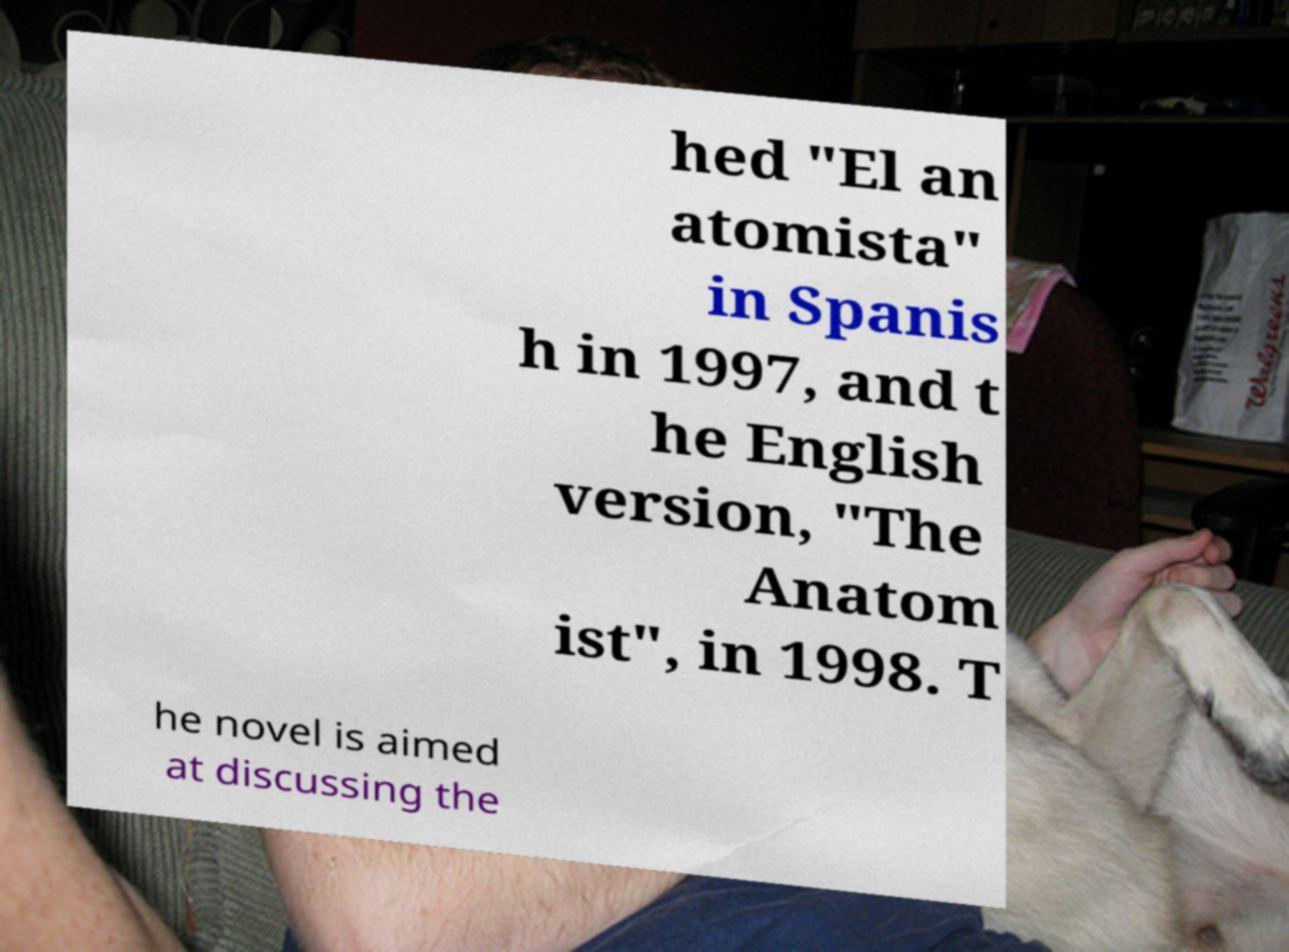Could you assist in decoding the text presented in this image and type it out clearly? hed "El an atomista" in Spanis h in 1997, and t he English version, "The Anatom ist", in 1998. T he novel is aimed at discussing the 